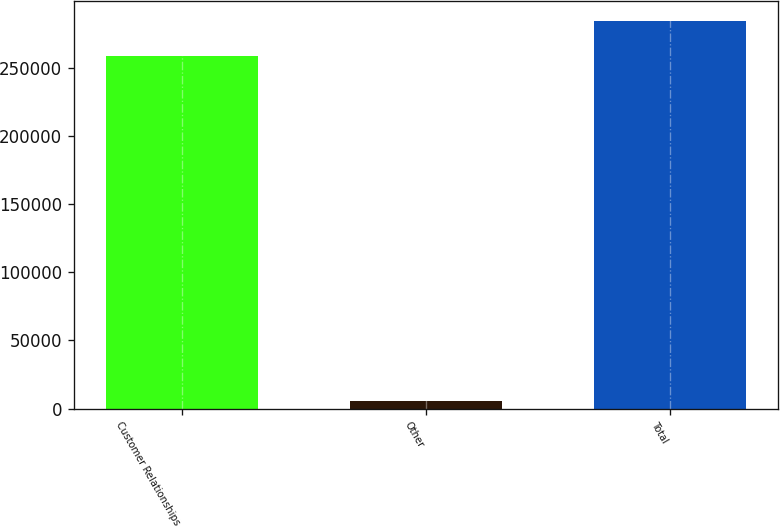<chart> <loc_0><loc_0><loc_500><loc_500><bar_chart><fcel>Customer Relationships<fcel>Other<fcel>Total<nl><fcel>258875<fcel>5290<fcel>284762<nl></chart> 